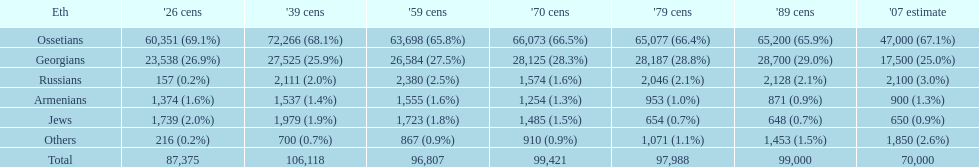Who is previous of the russians based on the list? Georgians. 